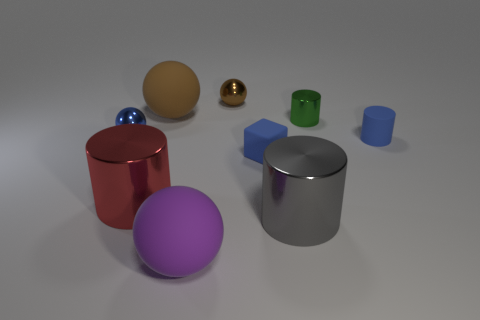There is a object that is right of the green shiny object; is it the same color as the tiny matte thing that is on the left side of the green cylinder?
Keep it short and to the point. Yes. How many other things are there of the same color as the tiny rubber cylinder?
Give a very brief answer. 2. How many objects are spheres on the left side of the large purple ball or blue things?
Offer a very short reply. 4. There is a tiny sphere that is on the right side of the metallic cylinder that is on the left side of the metal cylinder in front of the red cylinder; what is its material?
Your response must be concise. Metal. Is the number of small balls that are to the right of the small blue metallic thing greater than the number of tiny blue rubber things in front of the large purple object?
Your answer should be very brief. Yes. How many spheres are purple objects or tiny gray things?
Ensure brevity in your answer.  1. How many brown shiny things are to the left of the brown sphere that is on the right side of the large rubber sphere that is behind the tiny metallic cylinder?
Your response must be concise. 0. What is the material of the sphere that is the same color as the block?
Provide a succinct answer. Metal. Are there more metal spheres than balls?
Your answer should be compact. No. Is the size of the red cylinder the same as the brown rubber sphere?
Provide a succinct answer. Yes. 